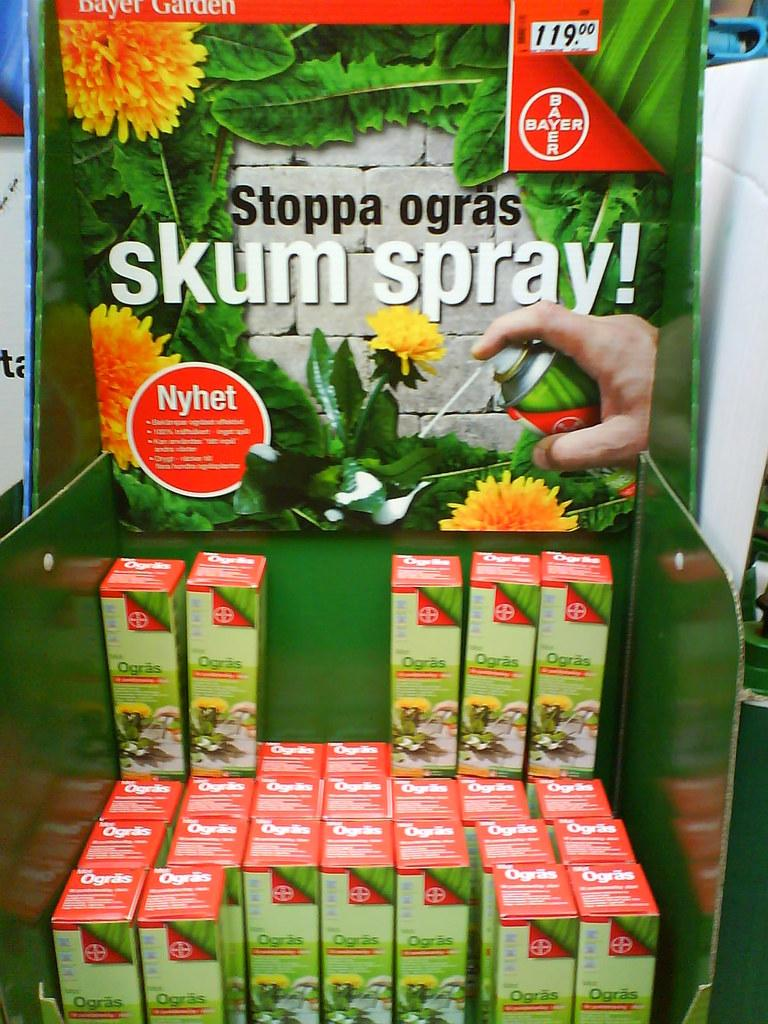What objects are in the foreground of the image? There are spray boxes in the foreground of the image. Where are the spray boxes located in relation to the banner? The spray boxes are in front of the banner. What can be seen behind the spray boxes? There is a banner behind the spray boxes. How many buttons are on the spray boxes in the image? There is no mention of buttons on the spray boxes in the image. 